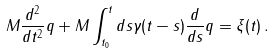<formula> <loc_0><loc_0><loc_500><loc_500>M \frac { d ^ { 2 } } { d t ^ { 2 } } q + M \int _ { t _ { 0 } } ^ { t } d s \gamma ( t - s ) \frac { d } { d s } q = \xi ( t ) \, .</formula> 